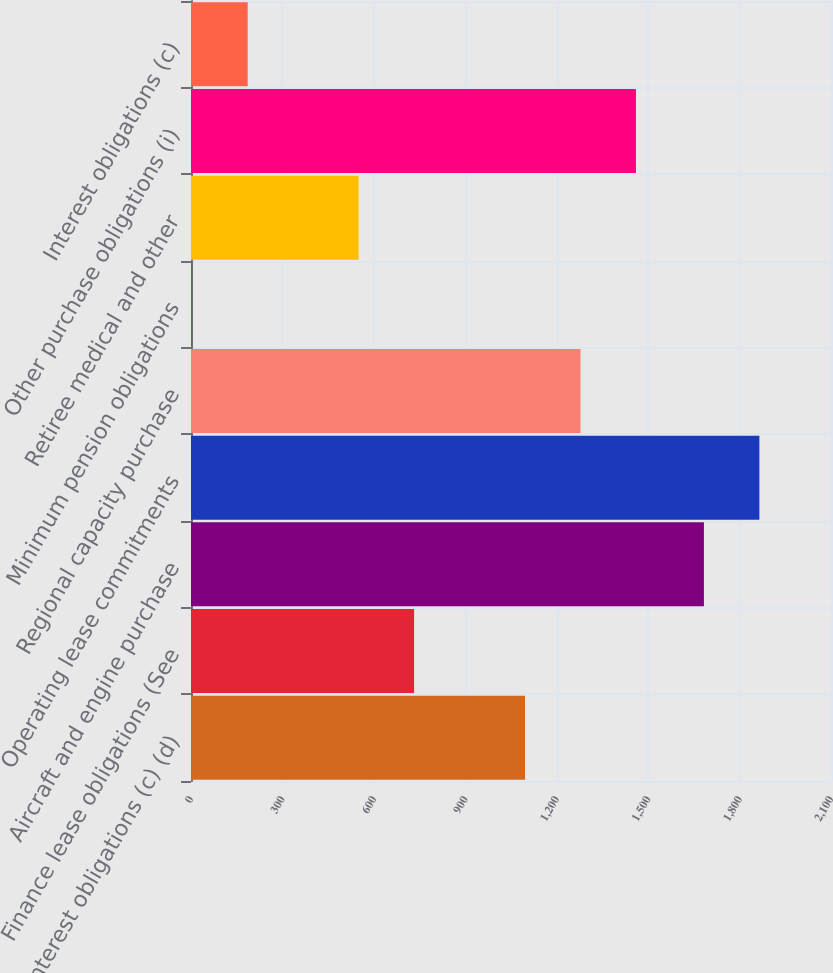Convert chart to OTSL. <chart><loc_0><loc_0><loc_500><loc_500><bar_chart><fcel>Interest obligations (c) (d)<fcel>Finance lease obligations (See<fcel>Aircraft and engine purchase<fcel>Operating lease commitments<fcel>Regional capacity purchase<fcel>Minimum pension obligations<fcel>Retiree medical and other<fcel>Other purchase obligations (i)<fcel>Interest obligations (c)<nl><fcel>1096<fcel>732<fcel>1683<fcel>1865<fcel>1278<fcel>4<fcel>550<fcel>1460<fcel>186<nl></chart> 